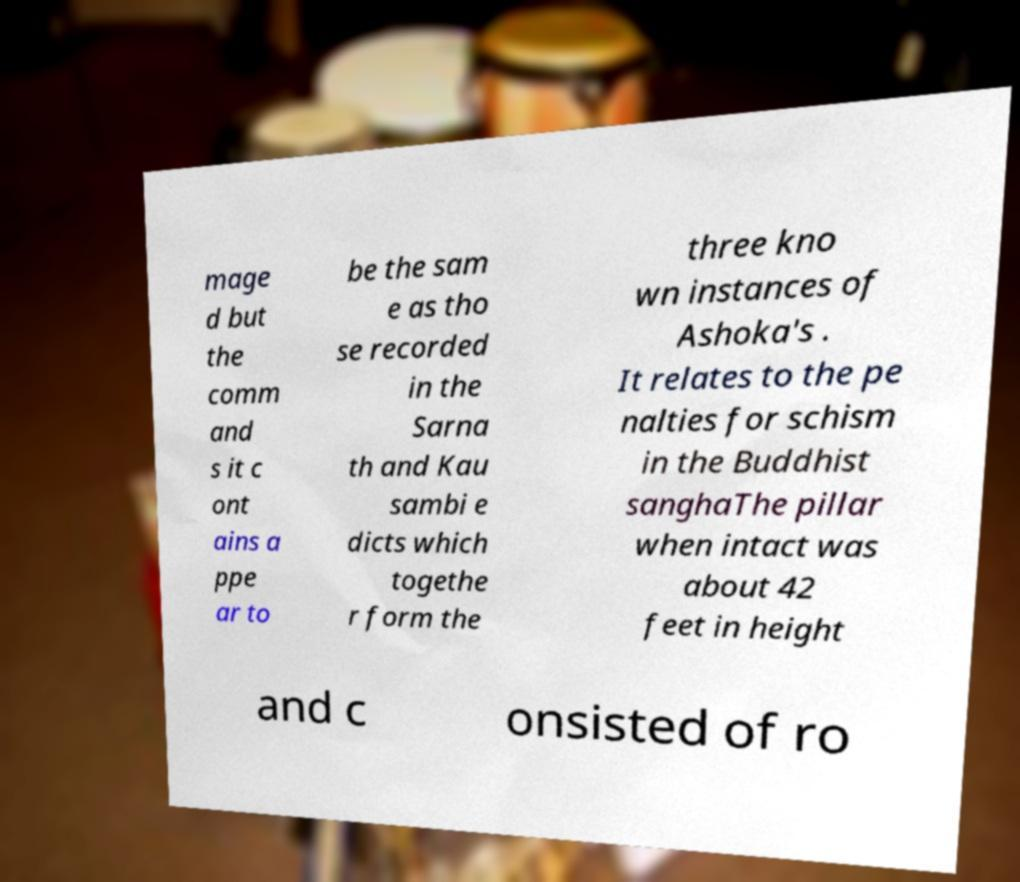Could you extract and type out the text from this image? mage d but the comm and s it c ont ains a ppe ar to be the sam e as tho se recorded in the Sarna th and Kau sambi e dicts which togethe r form the three kno wn instances of Ashoka's . It relates to the pe nalties for schism in the Buddhist sanghaThe pillar when intact was about 42 feet in height and c onsisted of ro 